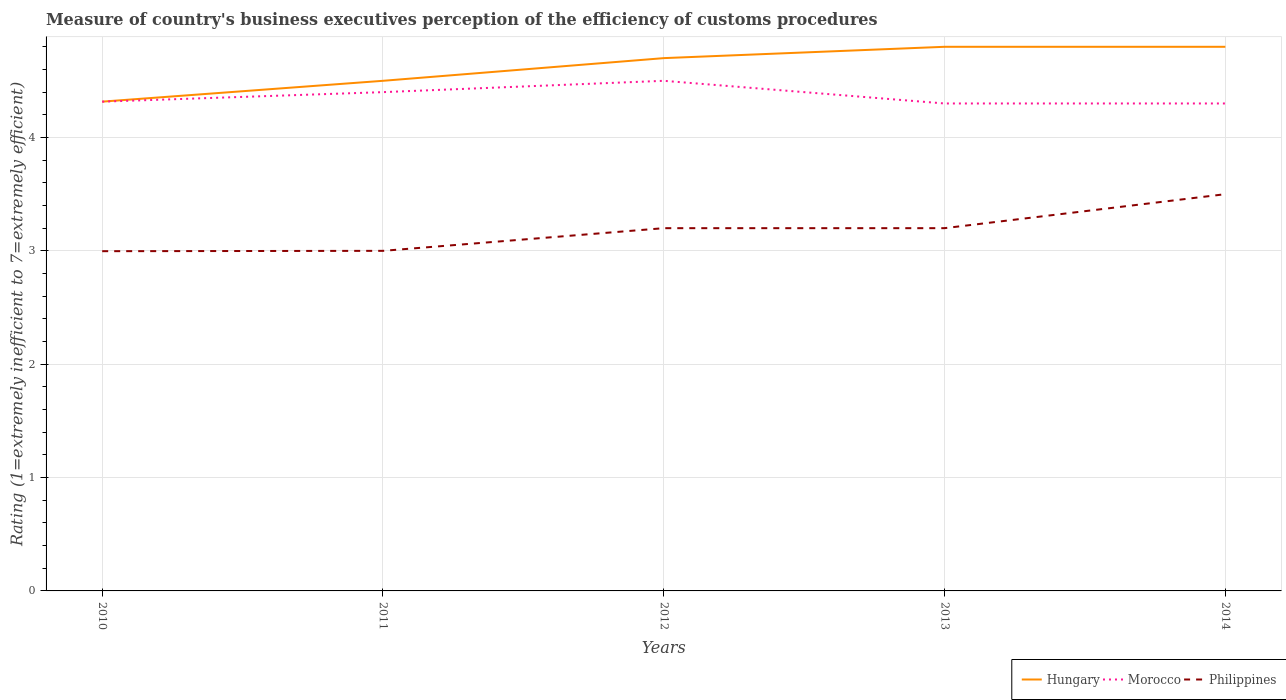How many different coloured lines are there?
Offer a very short reply. 3. Does the line corresponding to Morocco intersect with the line corresponding to Philippines?
Provide a succinct answer. No. Is the number of lines equal to the number of legend labels?
Give a very brief answer. Yes. Across all years, what is the maximum rating of the efficiency of customs procedure in Hungary?
Provide a succinct answer. 4.32. In which year was the rating of the efficiency of customs procedure in Hungary maximum?
Give a very brief answer. 2010. What is the total rating of the efficiency of customs procedure in Hungary in the graph?
Make the answer very short. -0.38. What is the difference between the highest and the second highest rating of the efficiency of customs procedure in Hungary?
Your response must be concise. 0.48. What is the difference between the highest and the lowest rating of the efficiency of customs procedure in Philippines?
Offer a terse response. 3. Is the rating of the efficiency of customs procedure in Morocco strictly greater than the rating of the efficiency of customs procedure in Hungary over the years?
Offer a very short reply. Yes. How many lines are there?
Your response must be concise. 3. How many years are there in the graph?
Keep it short and to the point. 5. What is the difference between two consecutive major ticks on the Y-axis?
Your answer should be very brief. 1. Where does the legend appear in the graph?
Offer a terse response. Bottom right. How many legend labels are there?
Give a very brief answer. 3. How are the legend labels stacked?
Your response must be concise. Horizontal. What is the title of the graph?
Your response must be concise. Measure of country's business executives perception of the efficiency of customs procedures. What is the label or title of the Y-axis?
Keep it short and to the point. Rating (1=extremely inefficient to 7=extremely efficient). What is the Rating (1=extremely inefficient to 7=extremely efficient) in Hungary in 2010?
Your answer should be very brief. 4.32. What is the Rating (1=extremely inefficient to 7=extremely efficient) of Morocco in 2010?
Keep it short and to the point. 4.32. What is the Rating (1=extremely inefficient to 7=extremely efficient) in Philippines in 2010?
Offer a very short reply. 3. What is the Rating (1=extremely inefficient to 7=extremely efficient) in Morocco in 2011?
Your answer should be compact. 4.4. What is the Rating (1=extremely inefficient to 7=extremely efficient) in Philippines in 2011?
Provide a succinct answer. 3. What is the Rating (1=extremely inefficient to 7=extremely efficient) in Morocco in 2012?
Provide a succinct answer. 4.5. What is the Rating (1=extremely inefficient to 7=extremely efficient) of Philippines in 2012?
Your answer should be compact. 3.2. What is the Rating (1=extremely inefficient to 7=extremely efficient) in Morocco in 2013?
Your answer should be compact. 4.3. Across all years, what is the maximum Rating (1=extremely inefficient to 7=extremely efficient) in Hungary?
Your answer should be very brief. 4.8. Across all years, what is the maximum Rating (1=extremely inefficient to 7=extremely efficient) of Morocco?
Your answer should be very brief. 4.5. Across all years, what is the minimum Rating (1=extremely inefficient to 7=extremely efficient) in Hungary?
Ensure brevity in your answer.  4.32. Across all years, what is the minimum Rating (1=extremely inefficient to 7=extremely efficient) of Morocco?
Give a very brief answer. 4.3. Across all years, what is the minimum Rating (1=extremely inefficient to 7=extremely efficient) in Philippines?
Ensure brevity in your answer.  3. What is the total Rating (1=extremely inefficient to 7=extremely efficient) of Hungary in the graph?
Your answer should be very brief. 23.12. What is the total Rating (1=extremely inefficient to 7=extremely efficient) of Morocco in the graph?
Provide a short and direct response. 21.82. What is the total Rating (1=extremely inefficient to 7=extremely efficient) of Philippines in the graph?
Give a very brief answer. 15.9. What is the difference between the Rating (1=extremely inefficient to 7=extremely efficient) in Hungary in 2010 and that in 2011?
Your answer should be compact. -0.18. What is the difference between the Rating (1=extremely inefficient to 7=extremely efficient) of Morocco in 2010 and that in 2011?
Make the answer very short. -0.08. What is the difference between the Rating (1=extremely inefficient to 7=extremely efficient) in Philippines in 2010 and that in 2011?
Make the answer very short. -0. What is the difference between the Rating (1=extremely inefficient to 7=extremely efficient) in Hungary in 2010 and that in 2012?
Keep it short and to the point. -0.38. What is the difference between the Rating (1=extremely inefficient to 7=extremely efficient) of Morocco in 2010 and that in 2012?
Your answer should be very brief. -0.18. What is the difference between the Rating (1=extremely inefficient to 7=extremely efficient) of Philippines in 2010 and that in 2012?
Your answer should be very brief. -0.2. What is the difference between the Rating (1=extremely inefficient to 7=extremely efficient) of Hungary in 2010 and that in 2013?
Your response must be concise. -0.48. What is the difference between the Rating (1=extremely inefficient to 7=extremely efficient) of Morocco in 2010 and that in 2013?
Ensure brevity in your answer.  0.02. What is the difference between the Rating (1=extremely inefficient to 7=extremely efficient) of Philippines in 2010 and that in 2013?
Your answer should be compact. -0.2. What is the difference between the Rating (1=extremely inefficient to 7=extremely efficient) in Hungary in 2010 and that in 2014?
Offer a terse response. -0.48. What is the difference between the Rating (1=extremely inefficient to 7=extremely efficient) of Morocco in 2010 and that in 2014?
Offer a terse response. 0.02. What is the difference between the Rating (1=extremely inefficient to 7=extremely efficient) of Philippines in 2010 and that in 2014?
Keep it short and to the point. -0.5. What is the difference between the Rating (1=extremely inefficient to 7=extremely efficient) in Morocco in 2011 and that in 2012?
Your answer should be very brief. -0.1. What is the difference between the Rating (1=extremely inefficient to 7=extremely efficient) of Hungary in 2011 and that in 2014?
Offer a terse response. -0.3. What is the difference between the Rating (1=extremely inefficient to 7=extremely efficient) of Philippines in 2011 and that in 2014?
Your answer should be very brief. -0.5. What is the difference between the Rating (1=extremely inefficient to 7=extremely efficient) of Hungary in 2012 and that in 2013?
Your response must be concise. -0.1. What is the difference between the Rating (1=extremely inefficient to 7=extremely efficient) in Philippines in 2012 and that in 2014?
Your answer should be compact. -0.3. What is the difference between the Rating (1=extremely inefficient to 7=extremely efficient) in Morocco in 2013 and that in 2014?
Ensure brevity in your answer.  0. What is the difference between the Rating (1=extremely inefficient to 7=extremely efficient) of Hungary in 2010 and the Rating (1=extremely inefficient to 7=extremely efficient) of Morocco in 2011?
Keep it short and to the point. -0.08. What is the difference between the Rating (1=extremely inefficient to 7=extremely efficient) of Hungary in 2010 and the Rating (1=extremely inefficient to 7=extremely efficient) of Philippines in 2011?
Your answer should be very brief. 1.32. What is the difference between the Rating (1=extremely inefficient to 7=extremely efficient) in Morocco in 2010 and the Rating (1=extremely inefficient to 7=extremely efficient) in Philippines in 2011?
Keep it short and to the point. 1.32. What is the difference between the Rating (1=extremely inefficient to 7=extremely efficient) in Hungary in 2010 and the Rating (1=extremely inefficient to 7=extremely efficient) in Morocco in 2012?
Make the answer very short. -0.18. What is the difference between the Rating (1=extremely inefficient to 7=extremely efficient) of Hungary in 2010 and the Rating (1=extremely inefficient to 7=extremely efficient) of Philippines in 2012?
Offer a terse response. 1.12. What is the difference between the Rating (1=extremely inefficient to 7=extremely efficient) of Morocco in 2010 and the Rating (1=extremely inefficient to 7=extremely efficient) of Philippines in 2012?
Your answer should be very brief. 1.12. What is the difference between the Rating (1=extremely inefficient to 7=extremely efficient) of Hungary in 2010 and the Rating (1=extremely inefficient to 7=extremely efficient) of Morocco in 2013?
Your answer should be compact. 0.02. What is the difference between the Rating (1=extremely inefficient to 7=extremely efficient) in Hungary in 2010 and the Rating (1=extremely inefficient to 7=extremely efficient) in Philippines in 2013?
Your response must be concise. 1.12. What is the difference between the Rating (1=extremely inefficient to 7=extremely efficient) of Morocco in 2010 and the Rating (1=extremely inefficient to 7=extremely efficient) of Philippines in 2013?
Ensure brevity in your answer.  1.12. What is the difference between the Rating (1=extremely inefficient to 7=extremely efficient) of Hungary in 2010 and the Rating (1=extremely inefficient to 7=extremely efficient) of Morocco in 2014?
Offer a very short reply. 0.02. What is the difference between the Rating (1=extremely inefficient to 7=extremely efficient) in Hungary in 2010 and the Rating (1=extremely inefficient to 7=extremely efficient) in Philippines in 2014?
Ensure brevity in your answer.  0.82. What is the difference between the Rating (1=extremely inefficient to 7=extremely efficient) of Morocco in 2010 and the Rating (1=extremely inefficient to 7=extremely efficient) of Philippines in 2014?
Your answer should be very brief. 0.82. What is the difference between the Rating (1=extremely inefficient to 7=extremely efficient) of Hungary in 2011 and the Rating (1=extremely inefficient to 7=extremely efficient) of Morocco in 2013?
Keep it short and to the point. 0.2. What is the difference between the Rating (1=extremely inefficient to 7=extremely efficient) in Morocco in 2011 and the Rating (1=extremely inefficient to 7=extremely efficient) in Philippines in 2014?
Make the answer very short. 0.9. What is the difference between the Rating (1=extremely inefficient to 7=extremely efficient) of Hungary in 2012 and the Rating (1=extremely inefficient to 7=extremely efficient) of Morocco in 2013?
Offer a terse response. 0.4. What is the difference between the Rating (1=extremely inefficient to 7=extremely efficient) in Hungary in 2012 and the Rating (1=extremely inefficient to 7=extremely efficient) in Philippines in 2013?
Provide a short and direct response. 1.5. What is the difference between the Rating (1=extremely inefficient to 7=extremely efficient) of Hungary in 2012 and the Rating (1=extremely inefficient to 7=extremely efficient) of Morocco in 2014?
Ensure brevity in your answer.  0.4. What is the difference between the Rating (1=extremely inefficient to 7=extremely efficient) in Morocco in 2012 and the Rating (1=extremely inefficient to 7=extremely efficient) in Philippines in 2014?
Give a very brief answer. 1. What is the difference between the Rating (1=extremely inefficient to 7=extremely efficient) in Hungary in 2013 and the Rating (1=extremely inefficient to 7=extremely efficient) in Philippines in 2014?
Offer a terse response. 1.3. What is the difference between the Rating (1=extremely inefficient to 7=extremely efficient) of Morocco in 2013 and the Rating (1=extremely inefficient to 7=extremely efficient) of Philippines in 2014?
Provide a short and direct response. 0.8. What is the average Rating (1=extremely inefficient to 7=extremely efficient) in Hungary per year?
Offer a very short reply. 4.62. What is the average Rating (1=extremely inefficient to 7=extremely efficient) of Morocco per year?
Your response must be concise. 4.36. What is the average Rating (1=extremely inefficient to 7=extremely efficient) in Philippines per year?
Provide a succinct answer. 3.18. In the year 2010, what is the difference between the Rating (1=extremely inefficient to 7=extremely efficient) of Hungary and Rating (1=extremely inefficient to 7=extremely efficient) of Philippines?
Ensure brevity in your answer.  1.32. In the year 2010, what is the difference between the Rating (1=extremely inefficient to 7=extremely efficient) in Morocco and Rating (1=extremely inefficient to 7=extremely efficient) in Philippines?
Make the answer very short. 1.32. In the year 2012, what is the difference between the Rating (1=extremely inefficient to 7=extremely efficient) in Hungary and Rating (1=extremely inefficient to 7=extremely efficient) in Morocco?
Provide a succinct answer. 0.2. In the year 2012, what is the difference between the Rating (1=extremely inefficient to 7=extremely efficient) in Hungary and Rating (1=extremely inefficient to 7=extremely efficient) in Philippines?
Keep it short and to the point. 1.5. In the year 2012, what is the difference between the Rating (1=extremely inefficient to 7=extremely efficient) of Morocco and Rating (1=extremely inefficient to 7=extremely efficient) of Philippines?
Your answer should be compact. 1.3. In the year 2013, what is the difference between the Rating (1=extremely inefficient to 7=extremely efficient) in Hungary and Rating (1=extremely inefficient to 7=extremely efficient) in Philippines?
Provide a succinct answer. 1.6. In the year 2014, what is the difference between the Rating (1=extremely inefficient to 7=extremely efficient) in Hungary and Rating (1=extremely inefficient to 7=extremely efficient) in Morocco?
Your response must be concise. 0.5. In the year 2014, what is the difference between the Rating (1=extremely inefficient to 7=extremely efficient) of Hungary and Rating (1=extremely inefficient to 7=extremely efficient) of Philippines?
Provide a succinct answer. 1.3. In the year 2014, what is the difference between the Rating (1=extremely inefficient to 7=extremely efficient) in Morocco and Rating (1=extremely inefficient to 7=extremely efficient) in Philippines?
Ensure brevity in your answer.  0.8. What is the ratio of the Rating (1=extremely inefficient to 7=extremely efficient) of Hungary in 2010 to that in 2011?
Ensure brevity in your answer.  0.96. What is the ratio of the Rating (1=extremely inefficient to 7=extremely efficient) of Morocco in 2010 to that in 2011?
Keep it short and to the point. 0.98. What is the ratio of the Rating (1=extremely inefficient to 7=extremely efficient) in Philippines in 2010 to that in 2011?
Keep it short and to the point. 1. What is the ratio of the Rating (1=extremely inefficient to 7=extremely efficient) in Hungary in 2010 to that in 2012?
Your answer should be compact. 0.92. What is the ratio of the Rating (1=extremely inefficient to 7=extremely efficient) in Morocco in 2010 to that in 2012?
Your response must be concise. 0.96. What is the ratio of the Rating (1=extremely inefficient to 7=extremely efficient) in Philippines in 2010 to that in 2012?
Provide a succinct answer. 0.94. What is the ratio of the Rating (1=extremely inefficient to 7=extremely efficient) in Hungary in 2010 to that in 2013?
Your answer should be compact. 0.9. What is the ratio of the Rating (1=extremely inefficient to 7=extremely efficient) of Morocco in 2010 to that in 2013?
Offer a terse response. 1. What is the ratio of the Rating (1=extremely inefficient to 7=extremely efficient) in Philippines in 2010 to that in 2013?
Keep it short and to the point. 0.94. What is the ratio of the Rating (1=extremely inefficient to 7=extremely efficient) in Hungary in 2010 to that in 2014?
Offer a very short reply. 0.9. What is the ratio of the Rating (1=extremely inefficient to 7=extremely efficient) of Morocco in 2010 to that in 2014?
Offer a terse response. 1. What is the ratio of the Rating (1=extremely inefficient to 7=extremely efficient) of Philippines in 2010 to that in 2014?
Give a very brief answer. 0.86. What is the ratio of the Rating (1=extremely inefficient to 7=extremely efficient) of Hungary in 2011 to that in 2012?
Give a very brief answer. 0.96. What is the ratio of the Rating (1=extremely inefficient to 7=extremely efficient) of Morocco in 2011 to that in 2012?
Give a very brief answer. 0.98. What is the ratio of the Rating (1=extremely inefficient to 7=extremely efficient) of Philippines in 2011 to that in 2012?
Your response must be concise. 0.94. What is the ratio of the Rating (1=extremely inefficient to 7=extremely efficient) in Morocco in 2011 to that in 2013?
Ensure brevity in your answer.  1.02. What is the ratio of the Rating (1=extremely inefficient to 7=extremely efficient) in Philippines in 2011 to that in 2013?
Provide a succinct answer. 0.94. What is the ratio of the Rating (1=extremely inefficient to 7=extremely efficient) of Hungary in 2011 to that in 2014?
Offer a very short reply. 0.94. What is the ratio of the Rating (1=extremely inefficient to 7=extremely efficient) of Morocco in 2011 to that in 2014?
Offer a very short reply. 1.02. What is the ratio of the Rating (1=extremely inefficient to 7=extremely efficient) of Hungary in 2012 to that in 2013?
Offer a terse response. 0.98. What is the ratio of the Rating (1=extremely inefficient to 7=extremely efficient) of Morocco in 2012 to that in 2013?
Your response must be concise. 1.05. What is the ratio of the Rating (1=extremely inefficient to 7=extremely efficient) of Hungary in 2012 to that in 2014?
Provide a succinct answer. 0.98. What is the ratio of the Rating (1=extremely inefficient to 7=extremely efficient) in Morocco in 2012 to that in 2014?
Give a very brief answer. 1.05. What is the ratio of the Rating (1=extremely inefficient to 7=extremely efficient) in Philippines in 2012 to that in 2014?
Provide a succinct answer. 0.91. What is the ratio of the Rating (1=extremely inefficient to 7=extremely efficient) in Philippines in 2013 to that in 2014?
Make the answer very short. 0.91. What is the difference between the highest and the second highest Rating (1=extremely inefficient to 7=extremely efficient) of Hungary?
Your answer should be compact. 0. What is the difference between the highest and the second highest Rating (1=extremely inefficient to 7=extremely efficient) of Morocco?
Offer a terse response. 0.1. What is the difference between the highest and the second highest Rating (1=extremely inefficient to 7=extremely efficient) of Philippines?
Ensure brevity in your answer.  0.3. What is the difference between the highest and the lowest Rating (1=extremely inefficient to 7=extremely efficient) of Hungary?
Ensure brevity in your answer.  0.48. What is the difference between the highest and the lowest Rating (1=extremely inefficient to 7=extremely efficient) of Philippines?
Your answer should be compact. 0.5. 